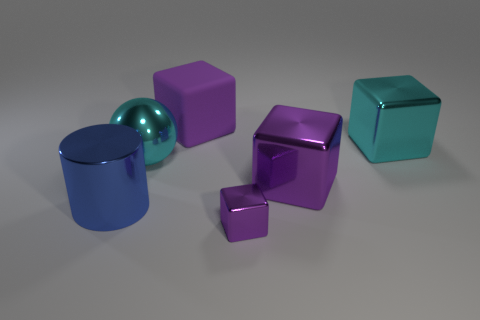What number of cylinders are either big things or large cyan metallic things?
Your response must be concise. 1. There is a cyan thing that is to the right of the purple matte cube; what number of big cyan shiny objects are left of it?
Provide a short and direct response. 1. Do the large purple metallic object and the large blue shiny thing have the same shape?
Your answer should be very brief. No. What is the size of the other cyan thing that is the same shape as the tiny metal object?
Offer a very short reply. Large. What is the shape of the cyan object behind the cyan object left of the large matte cube?
Offer a very short reply. Cube. How big is the sphere?
Provide a short and direct response. Large. The large purple matte object has what shape?
Offer a terse response. Cube. Is the shape of the tiny purple thing the same as the cyan metal thing that is behind the big metal sphere?
Your answer should be very brief. Yes. There is a purple shiny object that is behind the blue object; does it have the same shape as the big blue shiny object?
Your answer should be compact. No. How many large things are both left of the tiny metallic object and to the right of the big blue metallic cylinder?
Offer a terse response. 2. 